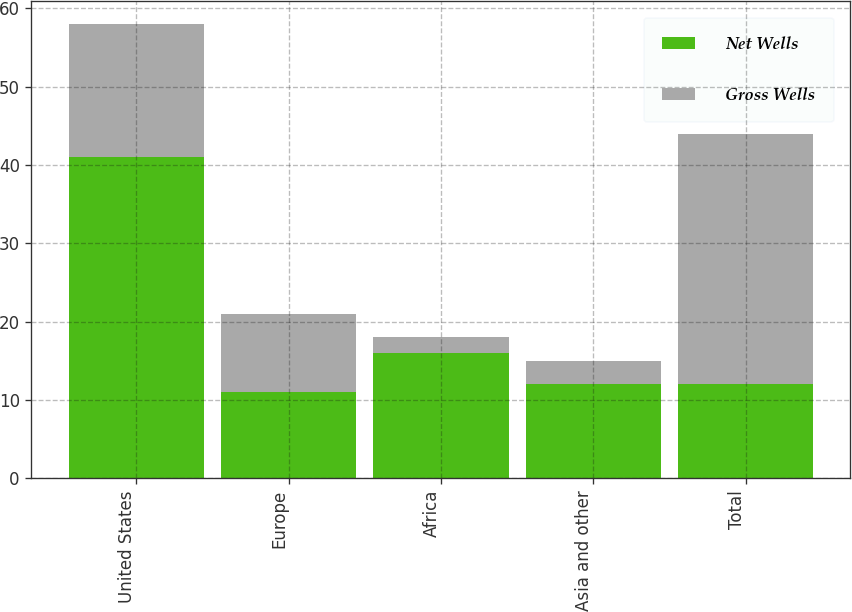Convert chart to OTSL. <chart><loc_0><loc_0><loc_500><loc_500><stacked_bar_chart><ecel><fcel>United States<fcel>Europe<fcel>Africa<fcel>Asia and other<fcel>Total<nl><fcel>Net Wells<fcel>41<fcel>11<fcel>16<fcel>12<fcel>12<nl><fcel>Gross Wells<fcel>17<fcel>10<fcel>2<fcel>3<fcel>32<nl></chart> 